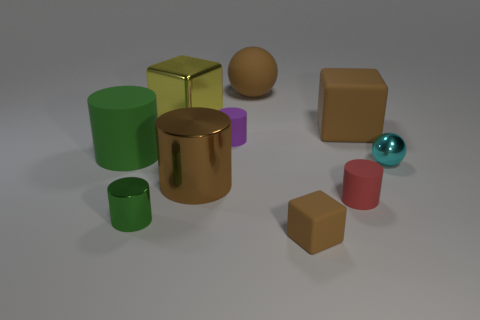Subtract all brown cylinders. How many cylinders are left? 4 Subtract all brown metallic cylinders. How many cylinders are left? 4 Subtract all blue cylinders. Subtract all gray blocks. How many cylinders are left? 5 Subtract all blocks. How many objects are left? 7 Subtract all tiny metal balls. Subtract all matte things. How many objects are left? 3 Add 9 big brown blocks. How many big brown blocks are left? 10 Add 5 brown metallic things. How many brown metallic things exist? 6 Subtract 1 red cylinders. How many objects are left? 9 